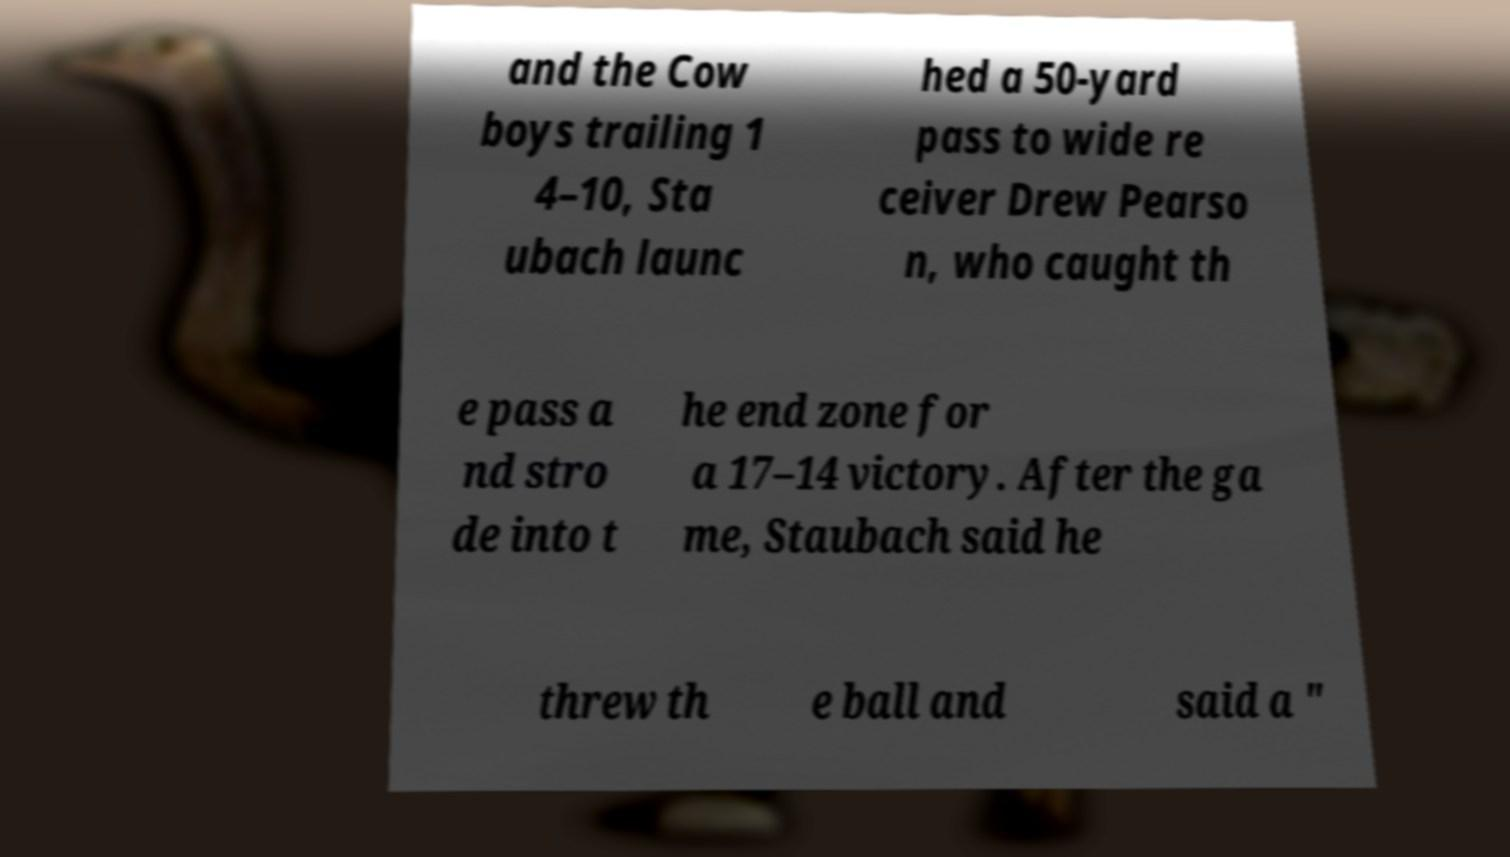Could you extract and type out the text from this image? and the Cow boys trailing 1 4–10, Sta ubach launc hed a 50-yard pass to wide re ceiver Drew Pearso n, who caught th e pass a nd stro de into t he end zone for a 17–14 victory. After the ga me, Staubach said he threw th e ball and said a " 